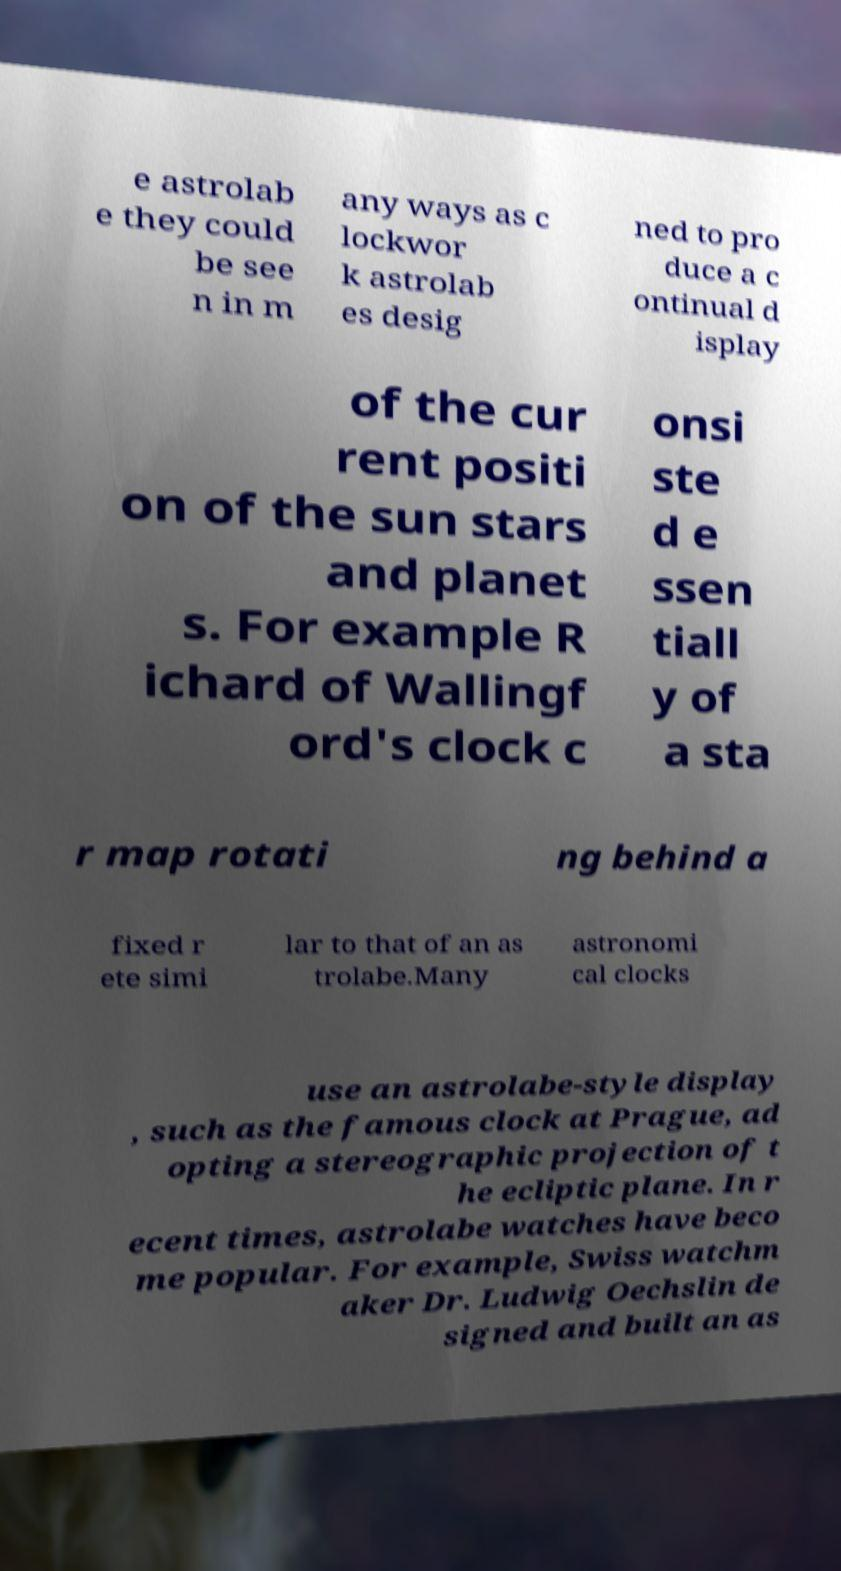Can you read and provide the text displayed in the image?This photo seems to have some interesting text. Can you extract and type it out for me? e astrolab e they could be see n in m any ways as c lockwor k astrolab es desig ned to pro duce a c ontinual d isplay of the cur rent positi on of the sun stars and planet s. For example R ichard of Wallingf ord's clock c onsi ste d e ssen tiall y of a sta r map rotati ng behind a fixed r ete simi lar to that of an as trolabe.Many astronomi cal clocks use an astrolabe-style display , such as the famous clock at Prague, ad opting a stereographic projection of t he ecliptic plane. In r ecent times, astrolabe watches have beco me popular. For example, Swiss watchm aker Dr. Ludwig Oechslin de signed and built an as 